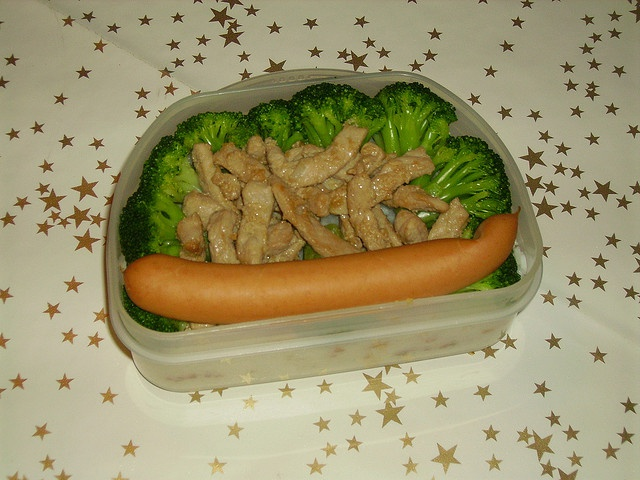Describe the objects in this image and their specific colors. I can see dining table in gray, tan, and beige tones, bowl in gray, olive, tan, and black tones, carrot in gray, red, orange, tan, and maroon tones, hot dog in gray, red, orange, tan, and maroon tones, and broccoli in gray, darkgreen, and olive tones in this image. 